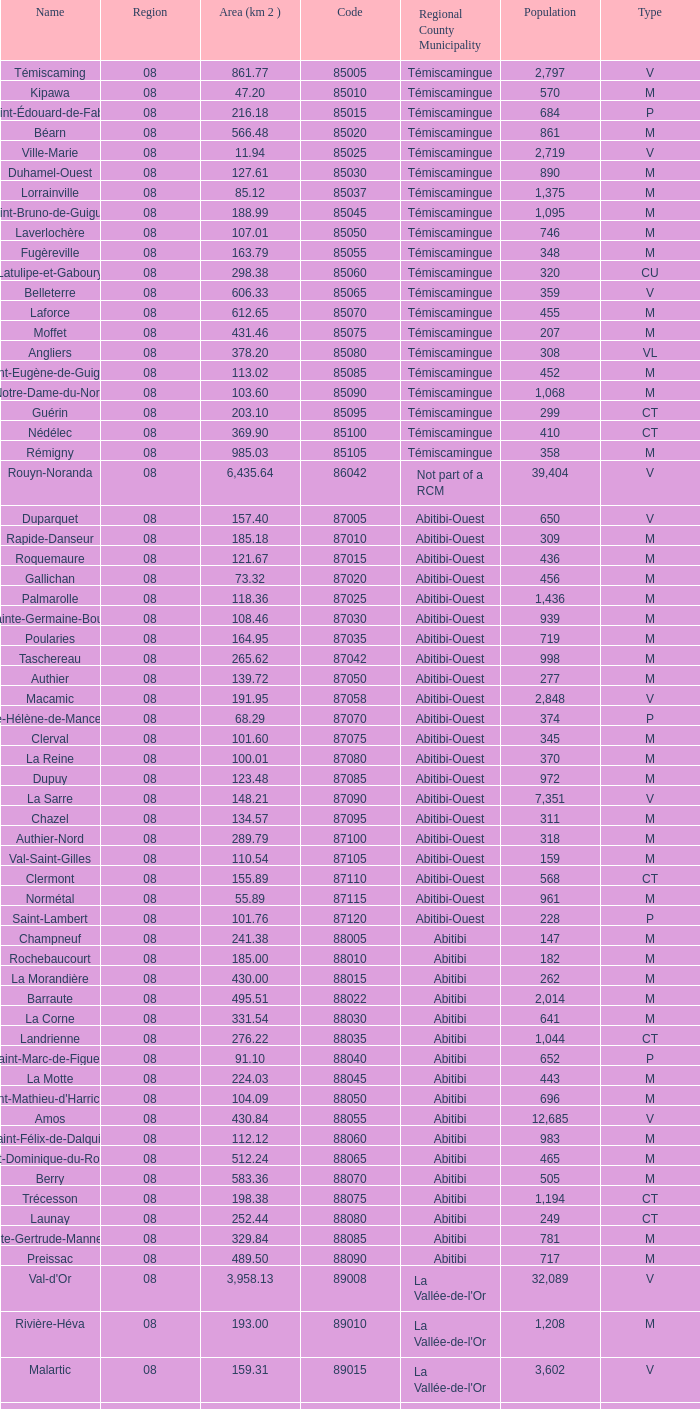What municipality has 719 people and is larger than 108.46 km2? Abitibi-Ouest. 